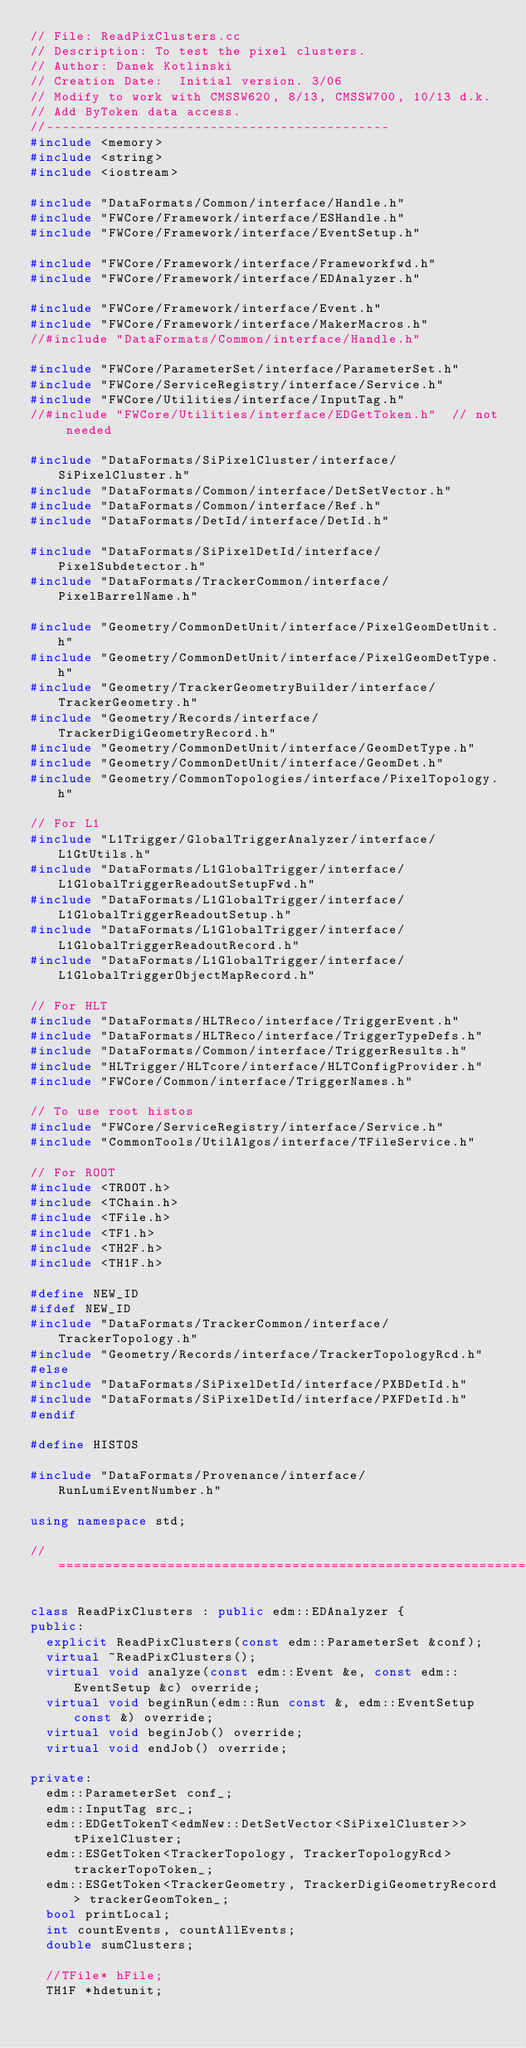Convert code to text. <code><loc_0><loc_0><loc_500><loc_500><_C++_>// File: ReadPixClusters.cc
// Description: To test the pixel clusters.
// Author: Danek Kotlinski
// Creation Date:  Initial version. 3/06
// Modify to work with CMSSW620, 8/13, CMSSW700, 10/13 d.k.
// Add ByToken data access.
//--------------------------------------------
#include <memory>
#include <string>
#include <iostream>

#include "DataFormats/Common/interface/Handle.h"
#include "FWCore/Framework/interface/ESHandle.h"
#include "FWCore/Framework/interface/EventSetup.h"

#include "FWCore/Framework/interface/Frameworkfwd.h"
#include "FWCore/Framework/interface/EDAnalyzer.h"

#include "FWCore/Framework/interface/Event.h"
#include "FWCore/Framework/interface/MakerMacros.h"
//#include "DataFormats/Common/interface/Handle.h"

#include "FWCore/ParameterSet/interface/ParameterSet.h"
#include "FWCore/ServiceRegistry/interface/Service.h"
#include "FWCore/Utilities/interface/InputTag.h"
//#include "FWCore/Utilities/interface/EDGetToken.h"  // not needed

#include "DataFormats/SiPixelCluster/interface/SiPixelCluster.h"
#include "DataFormats/Common/interface/DetSetVector.h"
#include "DataFormats/Common/interface/Ref.h"
#include "DataFormats/DetId/interface/DetId.h"

#include "DataFormats/SiPixelDetId/interface/PixelSubdetector.h"
#include "DataFormats/TrackerCommon/interface/PixelBarrelName.h"

#include "Geometry/CommonDetUnit/interface/PixelGeomDetUnit.h"
#include "Geometry/CommonDetUnit/interface/PixelGeomDetType.h"
#include "Geometry/TrackerGeometryBuilder/interface/TrackerGeometry.h"
#include "Geometry/Records/interface/TrackerDigiGeometryRecord.h"
#include "Geometry/CommonDetUnit/interface/GeomDetType.h"
#include "Geometry/CommonDetUnit/interface/GeomDet.h"
#include "Geometry/CommonTopologies/interface/PixelTopology.h"

// For L1
#include "L1Trigger/GlobalTriggerAnalyzer/interface/L1GtUtils.h"
#include "DataFormats/L1GlobalTrigger/interface/L1GlobalTriggerReadoutSetupFwd.h"
#include "DataFormats/L1GlobalTrigger/interface/L1GlobalTriggerReadoutSetup.h"
#include "DataFormats/L1GlobalTrigger/interface/L1GlobalTriggerReadoutRecord.h"
#include "DataFormats/L1GlobalTrigger/interface/L1GlobalTriggerObjectMapRecord.h"

// For HLT
#include "DataFormats/HLTReco/interface/TriggerEvent.h"
#include "DataFormats/HLTReco/interface/TriggerTypeDefs.h"
#include "DataFormats/Common/interface/TriggerResults.h"
#include "HLTrigger/HLTcore/interface/HLTConfigProvider.h"
#include "FWCore/Common/interface/TriggerNames.h"

// To use root histos
#include "FWCore/ServiceRegistry/interface/Service.h"
#include "CommonTools/UtilAlgos/interface/TFileService.h"

// For ROOT
#include <TROOT.h>
#include <TChain.h>
#include <TFile.h>
#include <TF1.h>
#include <TH2F.h>
#include <TH1F.h>

#define NEW_ID
#ifdef NEW_ID
#include "DataFormats/TrackerCommon/interface/TrackerTopology.h"
#include "Geometry/Records/interface/TrackerTopologyRcd.h"
#else
#include "DataFormats/SiPixelDetId/interface/PXBDetId.h"
#include "DataFormats/SiPixelDetId/interface/PXFDetId.h"
#endif

#define HISTOS

#include "DataFormats/Provenance/interface/RunLumiEventNumber.h"

using namespace std;

//=============================================================================

class ReadPixClusters : public edm::EDAnalyzer {
public:
  explicit ReadPixClusters(const edm::ParameterSet &conf);
  virtual ~ReadPixClusters();
  virtual void analyze(const edm::Event &e, const edm::EventSetup &c) override;
  virtual void beginRun(edm::Run const &, edm::EventSetup const &) override;
  virtual void beginJob() override;
  virtual void endJob() override;

private:
  edm::ParameterSet conf_;
  edm::InputTag src_;
  edm::EDGetTokenT<edmNew::DetSetVector<SiPixelCluster>> tPixelCluster;
  edm::ESGetToken<TrackerTopology, TrackerTopologyRcd> trackerTopoToken_;
  edm::ESGetToken<TrackerGeometry, TrackerDigiGeometryRecord> trackerGeomToken_;
  bool printLocal;
  int countEvents, countAllEvents;
  double sumClusters;

  //TFile* hFile;
  TH1F *hdetunit;</code> 